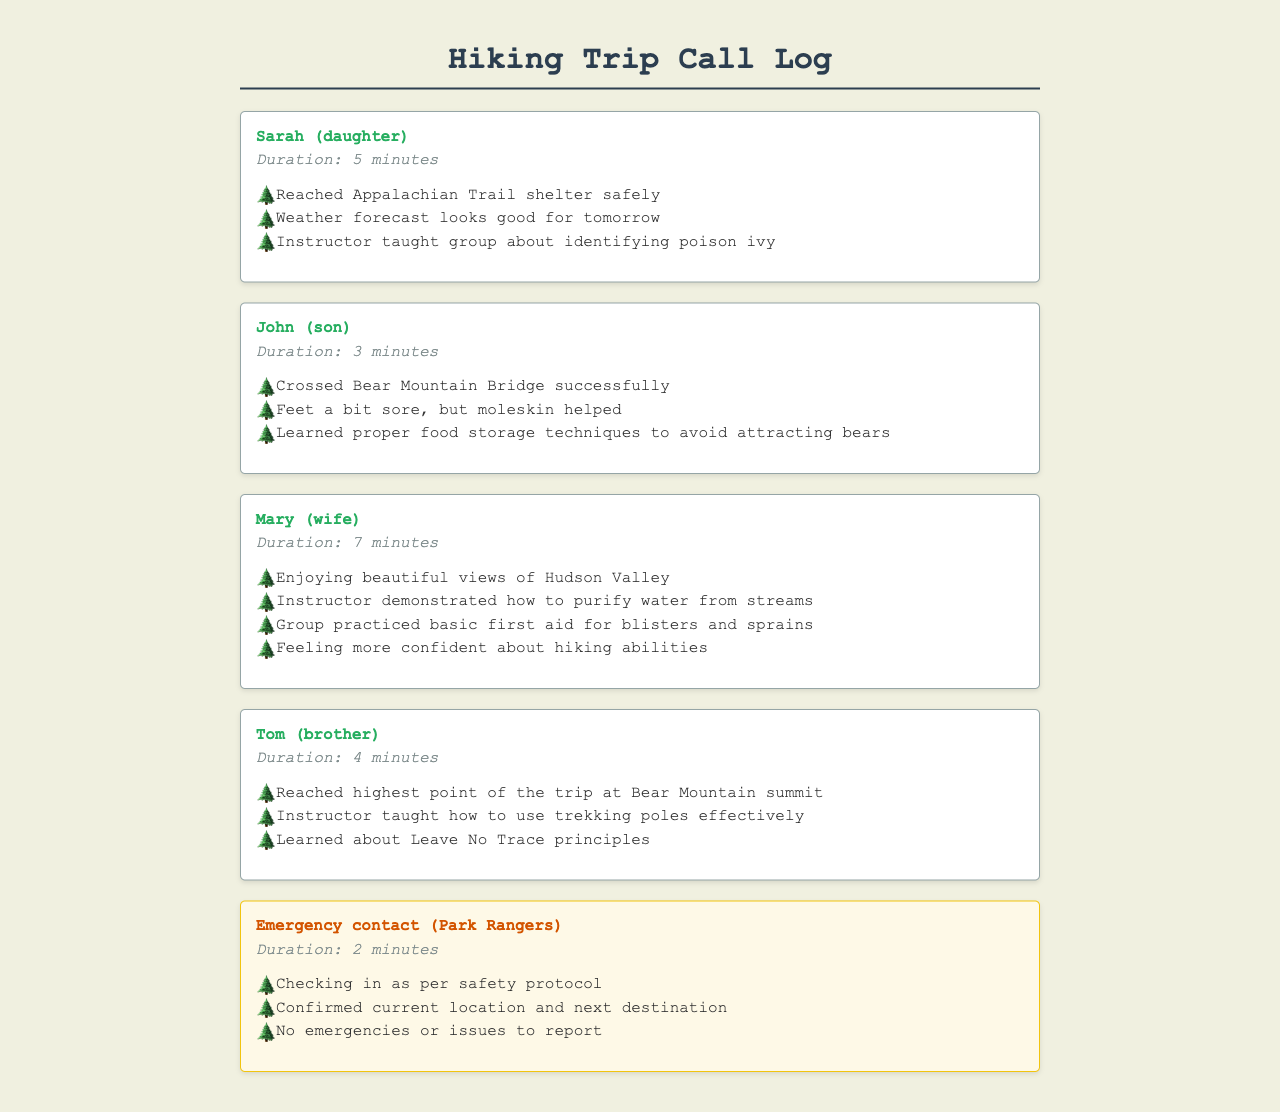What was the duration of the call with Sarah? The duration of the call is stated directly in the document, which mentions "Duration: 5 minutes."
Answer: 5 minutes What did the instructor teach about poison ivy? The document specifies that the instructor taught the group about identifying poison ivy.
Answer: Identifying poison ivy What is the highest point reached on the trip? The document mentions that the "highest point of the trip" is the Bear Mountain summit.
Answer: Bear Mountain summit What technique was learned to avoid attracting bears? The document states that the group learned "proper food storage techniques to avoid attracting bears."
Answer: Proper food storage techniques How long was the call with Mary? The document provides the call duration which is indicated as "Duration: 7 minutes."
Answer: 7 minutes What was checked in with the emergency contact? The document mentions that checking in was done "as per safety protocol."
Answer: Safety protocol Which family member has sore feet? It is mentioned in the document that John has "feet a bit sore."
Answer: John What principle was learned during the trip? The document notes that the group learned about "Leave No Trace principles."
Answer: Leave No Trace principles 